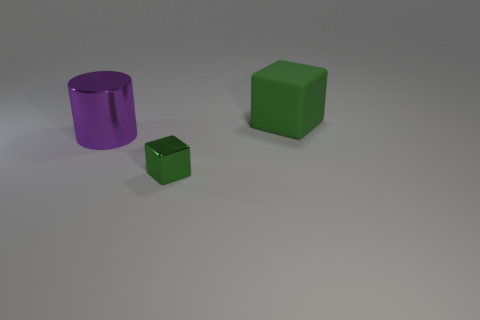Add 2 big cylinders. How many objects exist? 5 Subtract all cylinders. How many objects are left? 2 Add 2 tiny red matte things. How many tiny red matte things exist? 2 Subtract 0 purple blocks. How many objects are left? 3 Subtract all tiny metallic blocks. Subtract all big purple shiny cylinders. How many objects are left? 1 Add 2 tiny things. How many tiny things are left? 3 